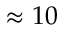<formula> <loc_0><loc_0><loc_500><loc_500>\approx 1 0</formula> 